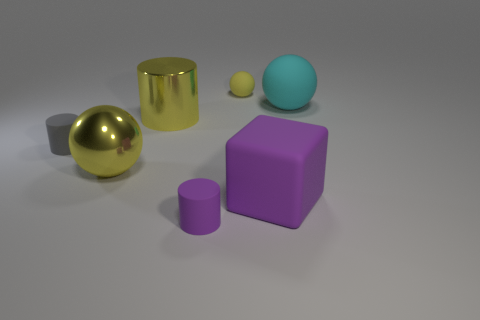How many cyan things are tiny objects or large rubber things?
Provide a succinct answer. 1. What color is the big block?
Provide a short and direct response. Purple. There is a purple block that is the same material as the large cyan ball; what size is it?
Offer a terse response. Large. What number of tiny yellow rubber objects have the same shape as the gray object?
Your answer should be very brief. 0. Is there anything else that has the same size as the cyan matte object?
Your answer should be very brief. Yes. What is the size of the purple matte thing behind the purple matte thing on the left side of the large purple matte cube?
Provide a short and direct response. Large. What material is the purple thing that is the same size as the gray matte object?
Offer a terse response. Rubber. Is there a tiny gray cylinder made of the same material as the large cyan ball?
Offer a very short reply. Yes. There is a small rubber object on the left side of the rubber cylinder that is on the right side of the small matte thing on the left side of the small purple matte cylinder; what is its color?
Your answer should be compact. Gray. Do the tiny rubber cylinder in front of the yellow metallic ball and the large thing that is on the right side of the rubber block have the same color?
Your answer should be very brief. No. 